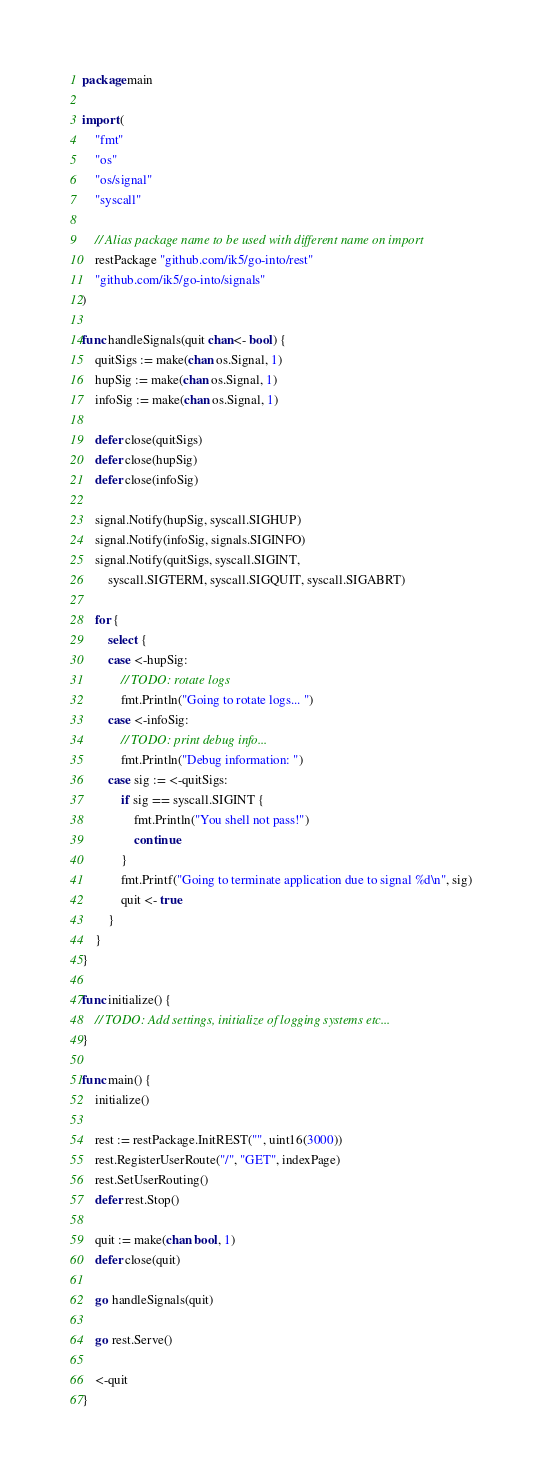<code> <loc_0><loc_0><loc_500><loc_500><_Go_>package main

import (
	"fmt"
	"os"
	"os/signal"
	"syscall"

	// Alias package name to be used with different name on import
	restPackage "github.com/ik5/go-into/rest"
	"github.com/ik5/go-into/signals"
)

func handleSignals(quit chan<- bool) {
	quitSigs := make(chan os.Signal, 1)
	hupSig := make(chan os.Signal, 1)
	infoSig := make(chan os.Signal, 1)

	defer close(quitSigs)
	defer close(hupSig)
	defer close(infoSig)

	signal.Notify(hupSig, syscall.SIGHUP)
	signal.Notify(infoSig, signals.SIGINFO)
	signal.Notify(quitSigs, syscall.SIGINT,
		syscall.SIGTERM, syscall.SIGQUIT, syscall.SIGABRT)

	for {
		select {
		case <-hupSig:
			// TODO: rotate logs
			fmt.Println("Going to rotate logs... ")
		case <-infoSig:
			// TODO: print debug info...
			fmt.Println("Debug information: ")
		case sig := <-quitSigs:
			if sig == syscall.SIGINT {
				fmt.Println("You shell not pass!")
				continue
			}
			fmt.Printf("Going to terminate application due to signal %d\n", sig)
			quit <- true
		}
	}
}

func initialize() {
	// TODO: Add settings, initialize of logging systems etc...
}

func main() {
	initialize()

	rest := restPackage.InitREST("", uint16(3000))
	rest.RegisterUserRoute("/", "GET", indexPage)
	rest.SetUserRouting()
	defer rest.Stop()

	quit := make(chan bool, 1)
	defer close(quit)

	go handleSignals(quit)

	go rest.Serve()

	<-quit
}
</code> 